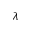<formula> <loc_0><loc_0><loc_500><loc_500>\lambda</formula> 